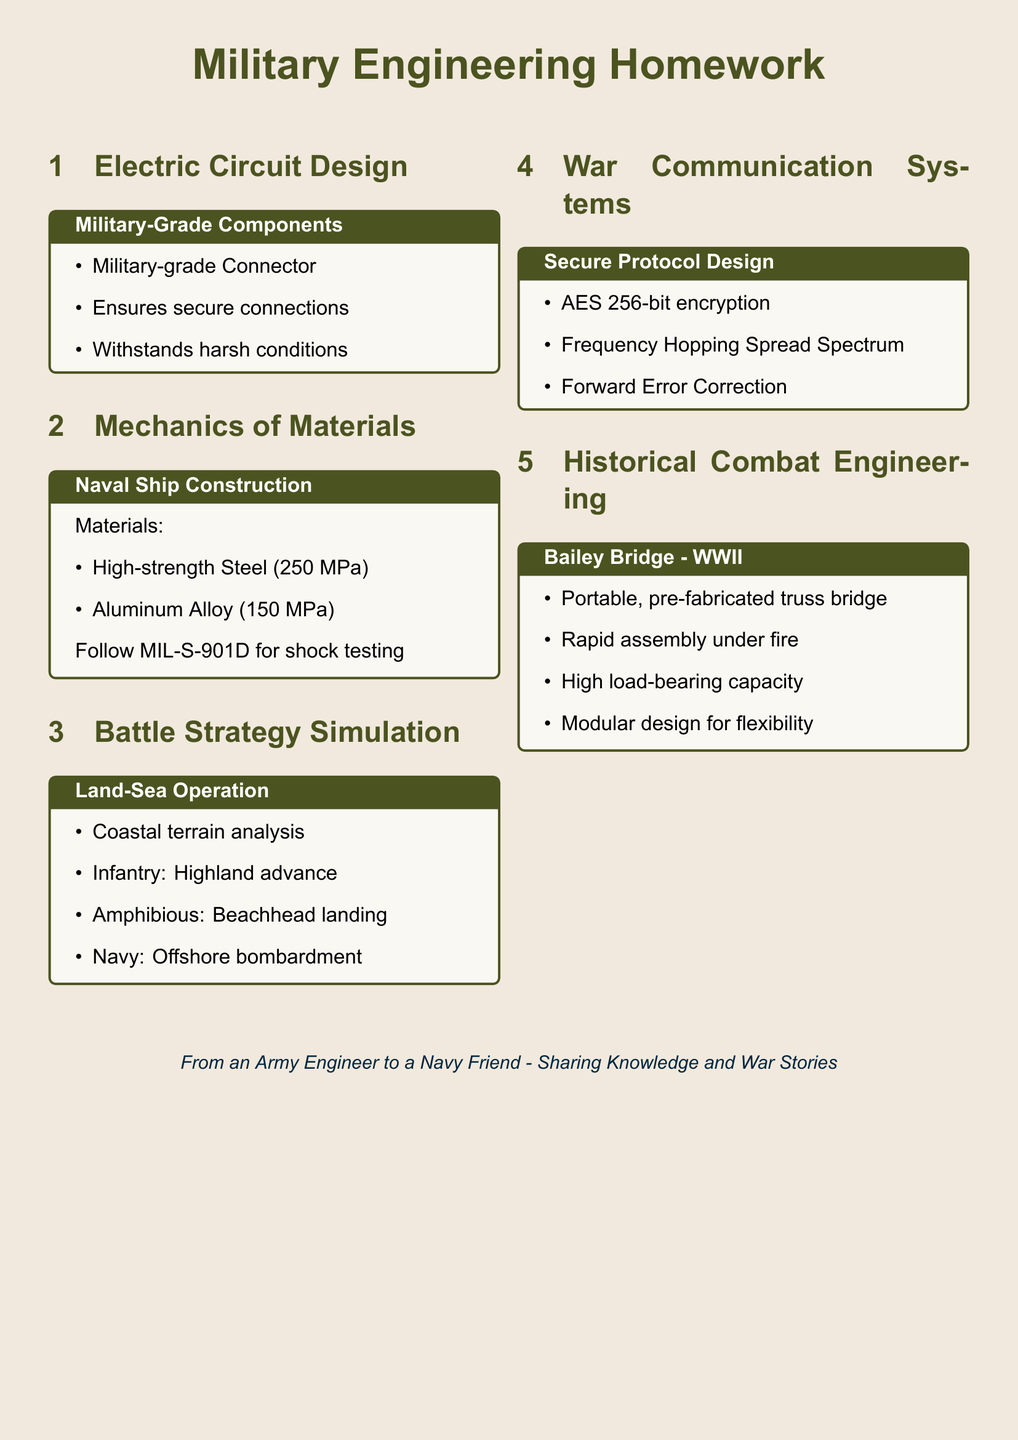What is the tensile strength of High-strength Steel? The tensile strength of High-strength Steel is listed in the Mechanics of Materials section of the document.
Answer: 250 MPa What type of encryption is used in the secure protocol design? The secure protocol design in the War Communication Systems section specifies the encryption method used for communication.
Answer: AES 256-bit encryption Which military-grade component ensures secure connections? The Military-Grade Components section of the Electric Circuit Design refers to components that ensure secure connections.
Answer: Military-grade Connector What is the purpose of the frequency management mentioned in the War Communication Systems? Frequency management in the context of the War Communication Systems involves ensuring reliable communication between units.
Answer: Frequency Hopping Spread Spectrum What engineering standard is followed for shock testing in naval ship construction? The Mechanics of Materials section specifies an engineering standard for naval ship construction and shock testing.
Answer: MIL-S-901D What type of bridge is described in the Historical Combat Engineering section? The Historical Combat Engineering section describes a specific type of military bridge used during World War II.
Answer: Bailey Bridge What is the load-bearing capacity characteristic of the Bailey Bridge? The Bailey Bridge's characteristics include its ability to handle significant weight as mentioned in the engineering project description.
Answer: High load-bearing capacity What strategy is suggested for the infantry in the Land-Sea Operation? The Battle Strategy Simulation section of the document outlines strategies for different military units, including infantry movements.
Answer: Highland advance 